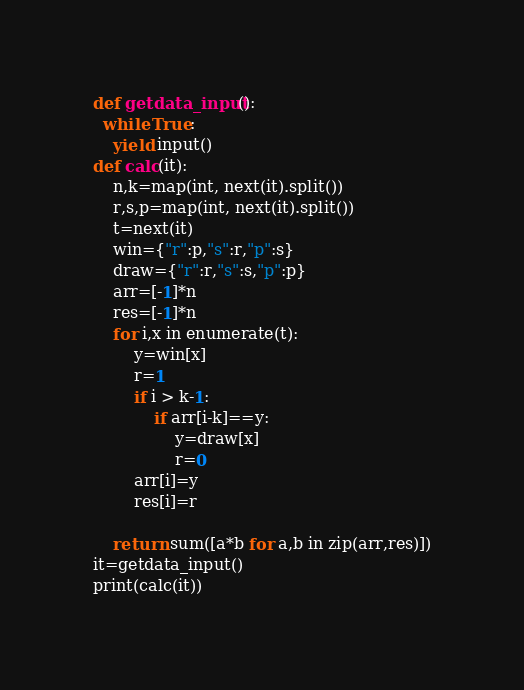Convert code to text. <code><loc_0><loc_0><loc_500><loc_500><_Python_>def getdata_input():
  while True:
    yield input()
def calc(it):
    n,k=map(int, next(it).split())
    r,s,p=map(int, next(it).split())
    t=next(it)
    win={"r":p,"s":r,"p":s}
    draw={"r":r,"s":s,"p":p}
    arr=[-1]*n
    res=[-1]*n
    for i,x in enumerate(t):
        y=win[x]
        r=1
        if i > k-1:
            if arr[i-k]==y:
                y=draw[x]
                r=0
        arr[i]=y
        res[i]=r
        
    return sum([a*b for a,b in zip(arr,res)])
it=getdata_input()
print(calc(it))

</code> 